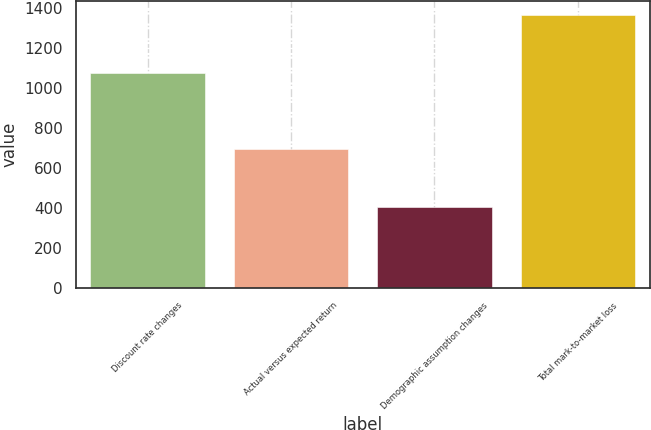Convert chart. <chart><loc_0><loc_0><loc_500><loc_500><bar_chart><fcel>Discount rate changes<fcel>Actual versus expected return<fcel>Demographic assumption changes<fcel>Total mark-to-market loss<nl><fcel>1076<fcel>696<fcel>404<fcel>1368<nl></chart> 